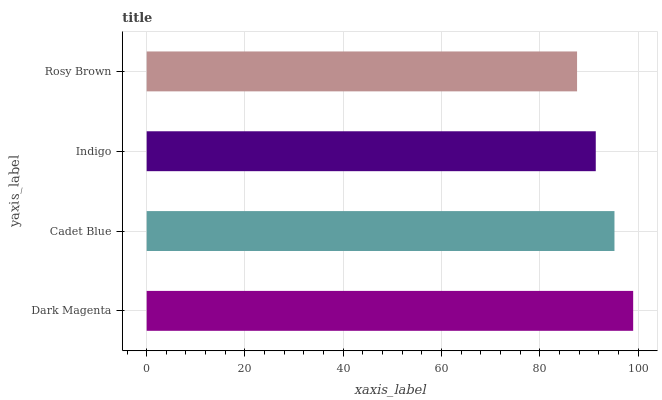Is Rosy Brown the minimum?
Answer yes or no. Yes. Is Dark Magenta the maximum?
Answer yes or no. Yes. Is Cadet Blue the minimum?
Answer yes or no. No. Is Cadet Blue the maximum?
Answer yes or no. No. Is Dark Magenta greater than Cadet Blue?
Answer yes or no. Yes. Is Cadet Blue less than Dark Magenta?
Answer yes or no. Yes. Is Cadet Blue greater than Dark Magenta?
Answer yes or no. No. Is Dark Magenta less than Cadet Blue?
Answer yes or no. No. Is Cadet Blue the high median?
Answer yes or no. Yes. Is Indigo the low median?
Answer yes or no. Yes. Is Dark Magenta the high median?
Answer yes or no. No. Is Rosy Brown the low median?
Answer yes or no. No. 